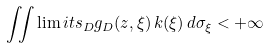Convert formula to latex. <formula><loc_0><loc_0><loc_500><loc_500>\iint \lim i t s _ { D } g _ { D } ( z , \xi ) \, k ( \xi ) \, d \sigma _ { \xi } < + \infty</formula> 